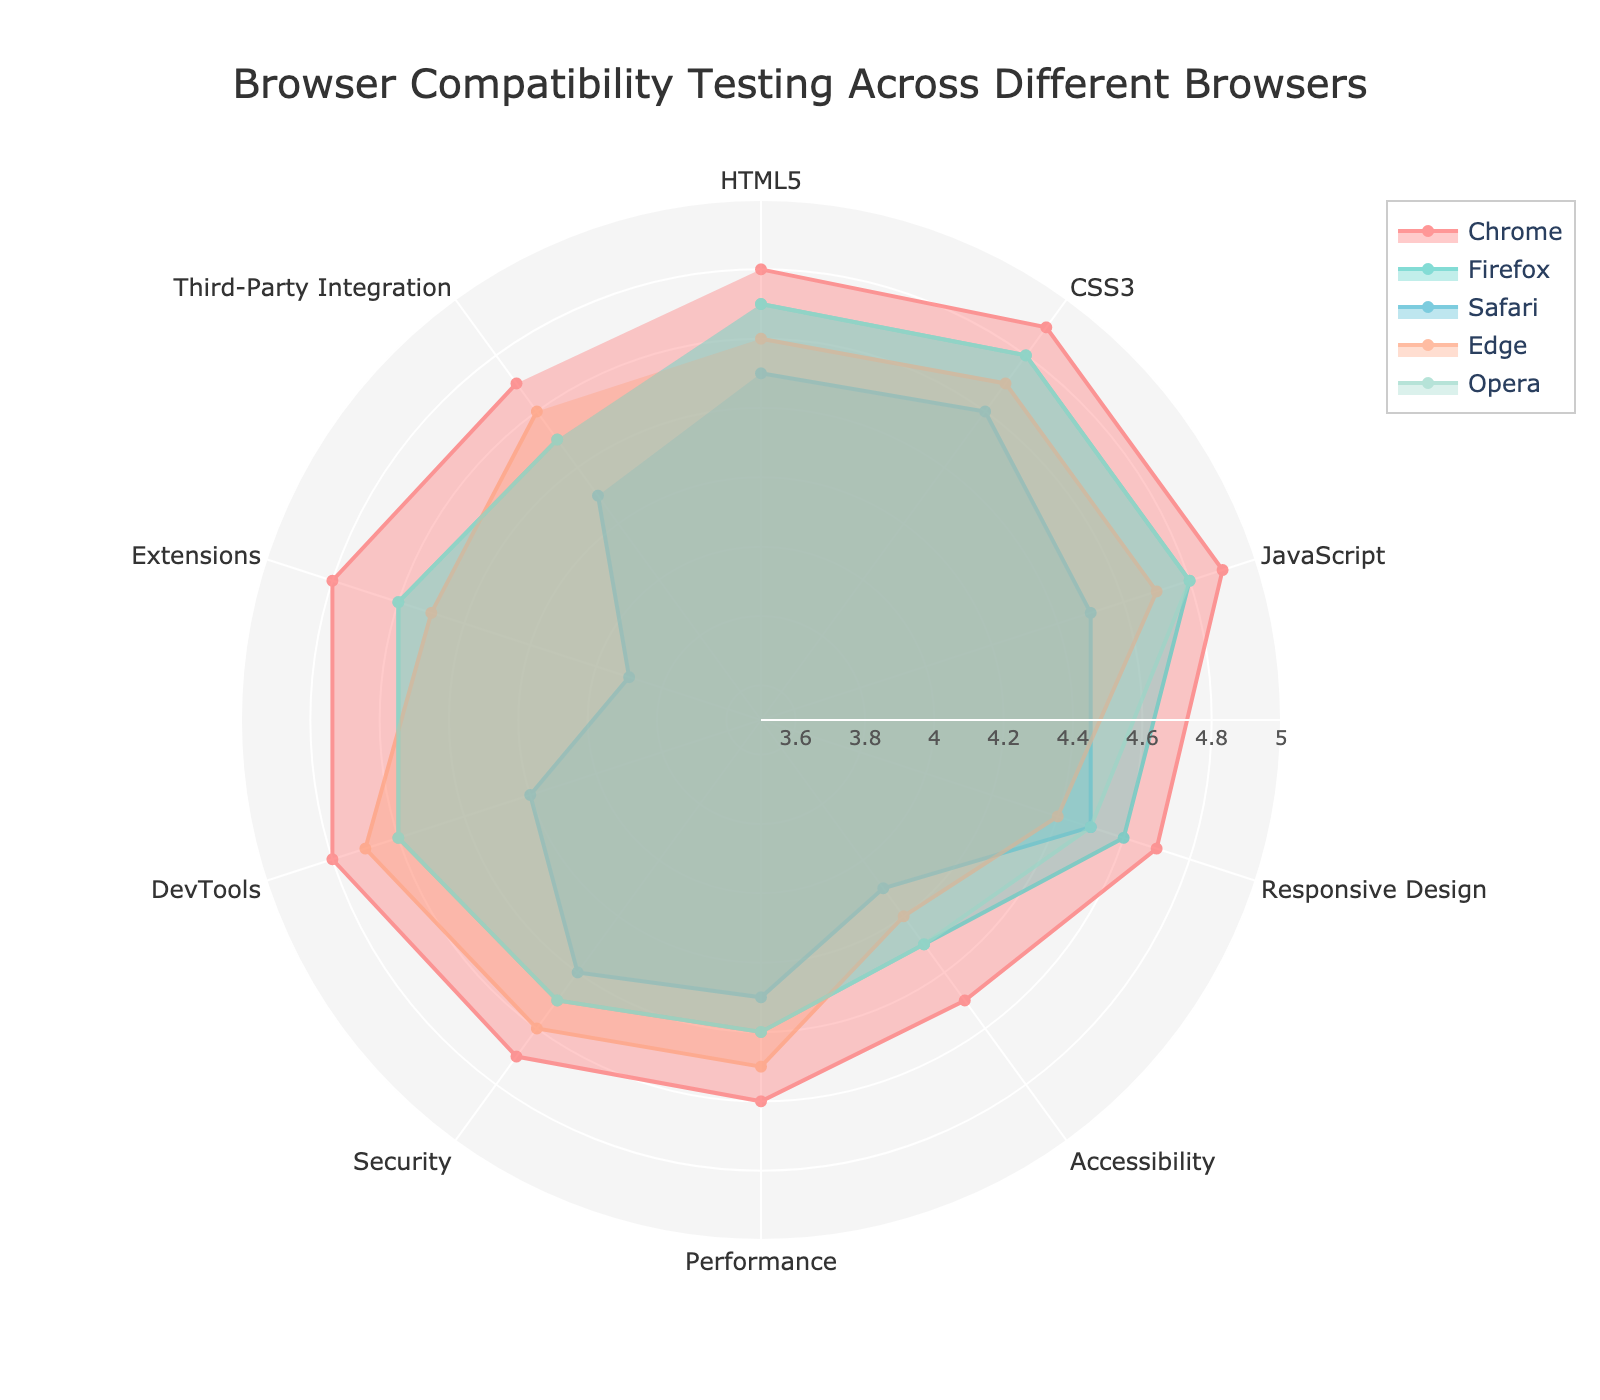What is the title of the radar chart? The title is located at the top of the chart, usually centered. By looking at that area, we can read the full title.
Answer: Browser Compatibility Testing Across Different Browsers Which browser scores the highest in CSS3? To answer this, we observe the values for each browser in the CSS3 category, then identify the maximum value.
Answer: Chrome What is the average score of Safari across all features? Add up all the scores for Safari across all features and divide by the total number of features (10). This calculation is (4.5 + 4.6 + 4.5 + 4.5 + 4.1 + 4.3 + 4.4 + 4.2 + 3.9 + 4.3) / 10 = 4.33
Answer: 4.33 Which browsers have equal scores for Extensions? Look at the values for the Extensions feature for each browser and identify which ones match. Both Firefox and Opera score 4.6.
Answer: Firefox and Opera Which feature has the lowest score across all browsers? Identify the lowest value in each feature column and then find the minimum of these values. Extensions for Safari with a score of 3.9 is the lowest.
Answer: Extensions (Safari) What are the scores for Performance in all browsers? Refer to the Performance category and list the scores for all browsers: Chrome - 4.6, Firefox - 4.4, Safari - 4.3, Edge - 4.5, Opera - 4.4.
Answer: Chrome: 4.6, Firefox: 4.4, Safari: 4.3, Edge: 4.5, Opera: 4.4 Which browser has the widest spread of scores across the features? The spread is the difference between the maximum and minimum scores for a browser. Calculate these differences for each browser and identify the highest. For Safari, the spread is 4.6 - 3.9 = 0.7, which is the largest.
Answer: Safari Among all browsers, which score highest in HTML5 and lowest in Performance? Look for the highest value in the HTML5 category and the lowest value in the Performance category. Chrome scores highest in HTML5 (4.8), and Safari scores lowest in Performance (4.3).
Answer: Chrome (HTML5), Safari (Performance) What is the total score of Edge for features Accessibility, Security, and DevTools? Sum the scores of Edge for these three features: 4.2 (Accessibility) + 4.6 (Security) + 4.7 (DevTools) = 13.5.
Answer: 13.5 